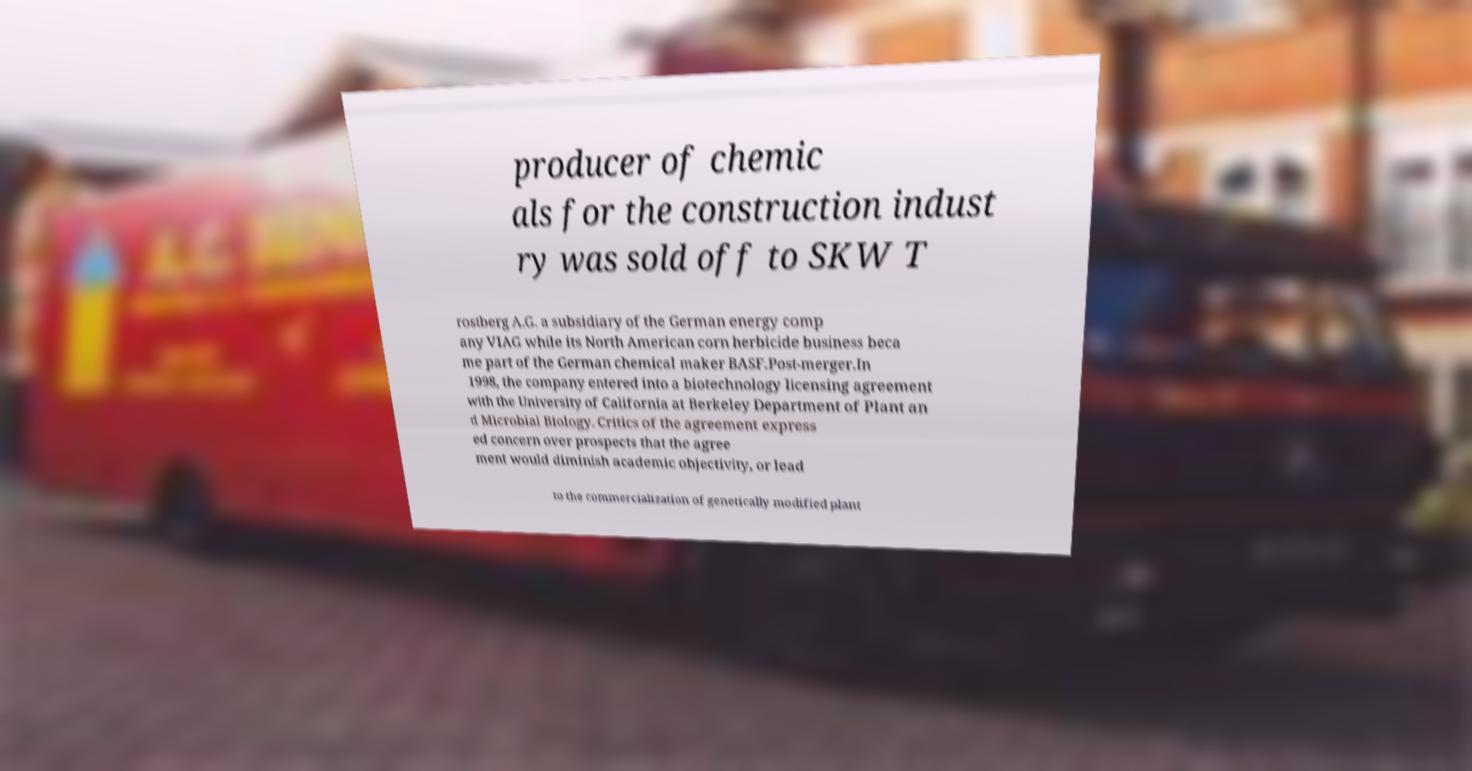There's text embedded in this image that I need extracted. Can you transcribe it verbatim? producer of chemic als for the construction indust ry was sold off to SKW T rostberg A.G. a subsidiary of the German energy comp any VIAG while its North American corn herbicide business beca me part of the German chemical maker BASF.Post-merger.In 1998, the company entered into a biotechnology licensing agreement with the University of California at Berkeley Department of Plant an d Microbial Biology. Critics of the agreement express ed concern over prospects that the agree ment would diminish academic objectivity, or lead to the commercialization of genetically modified plant 